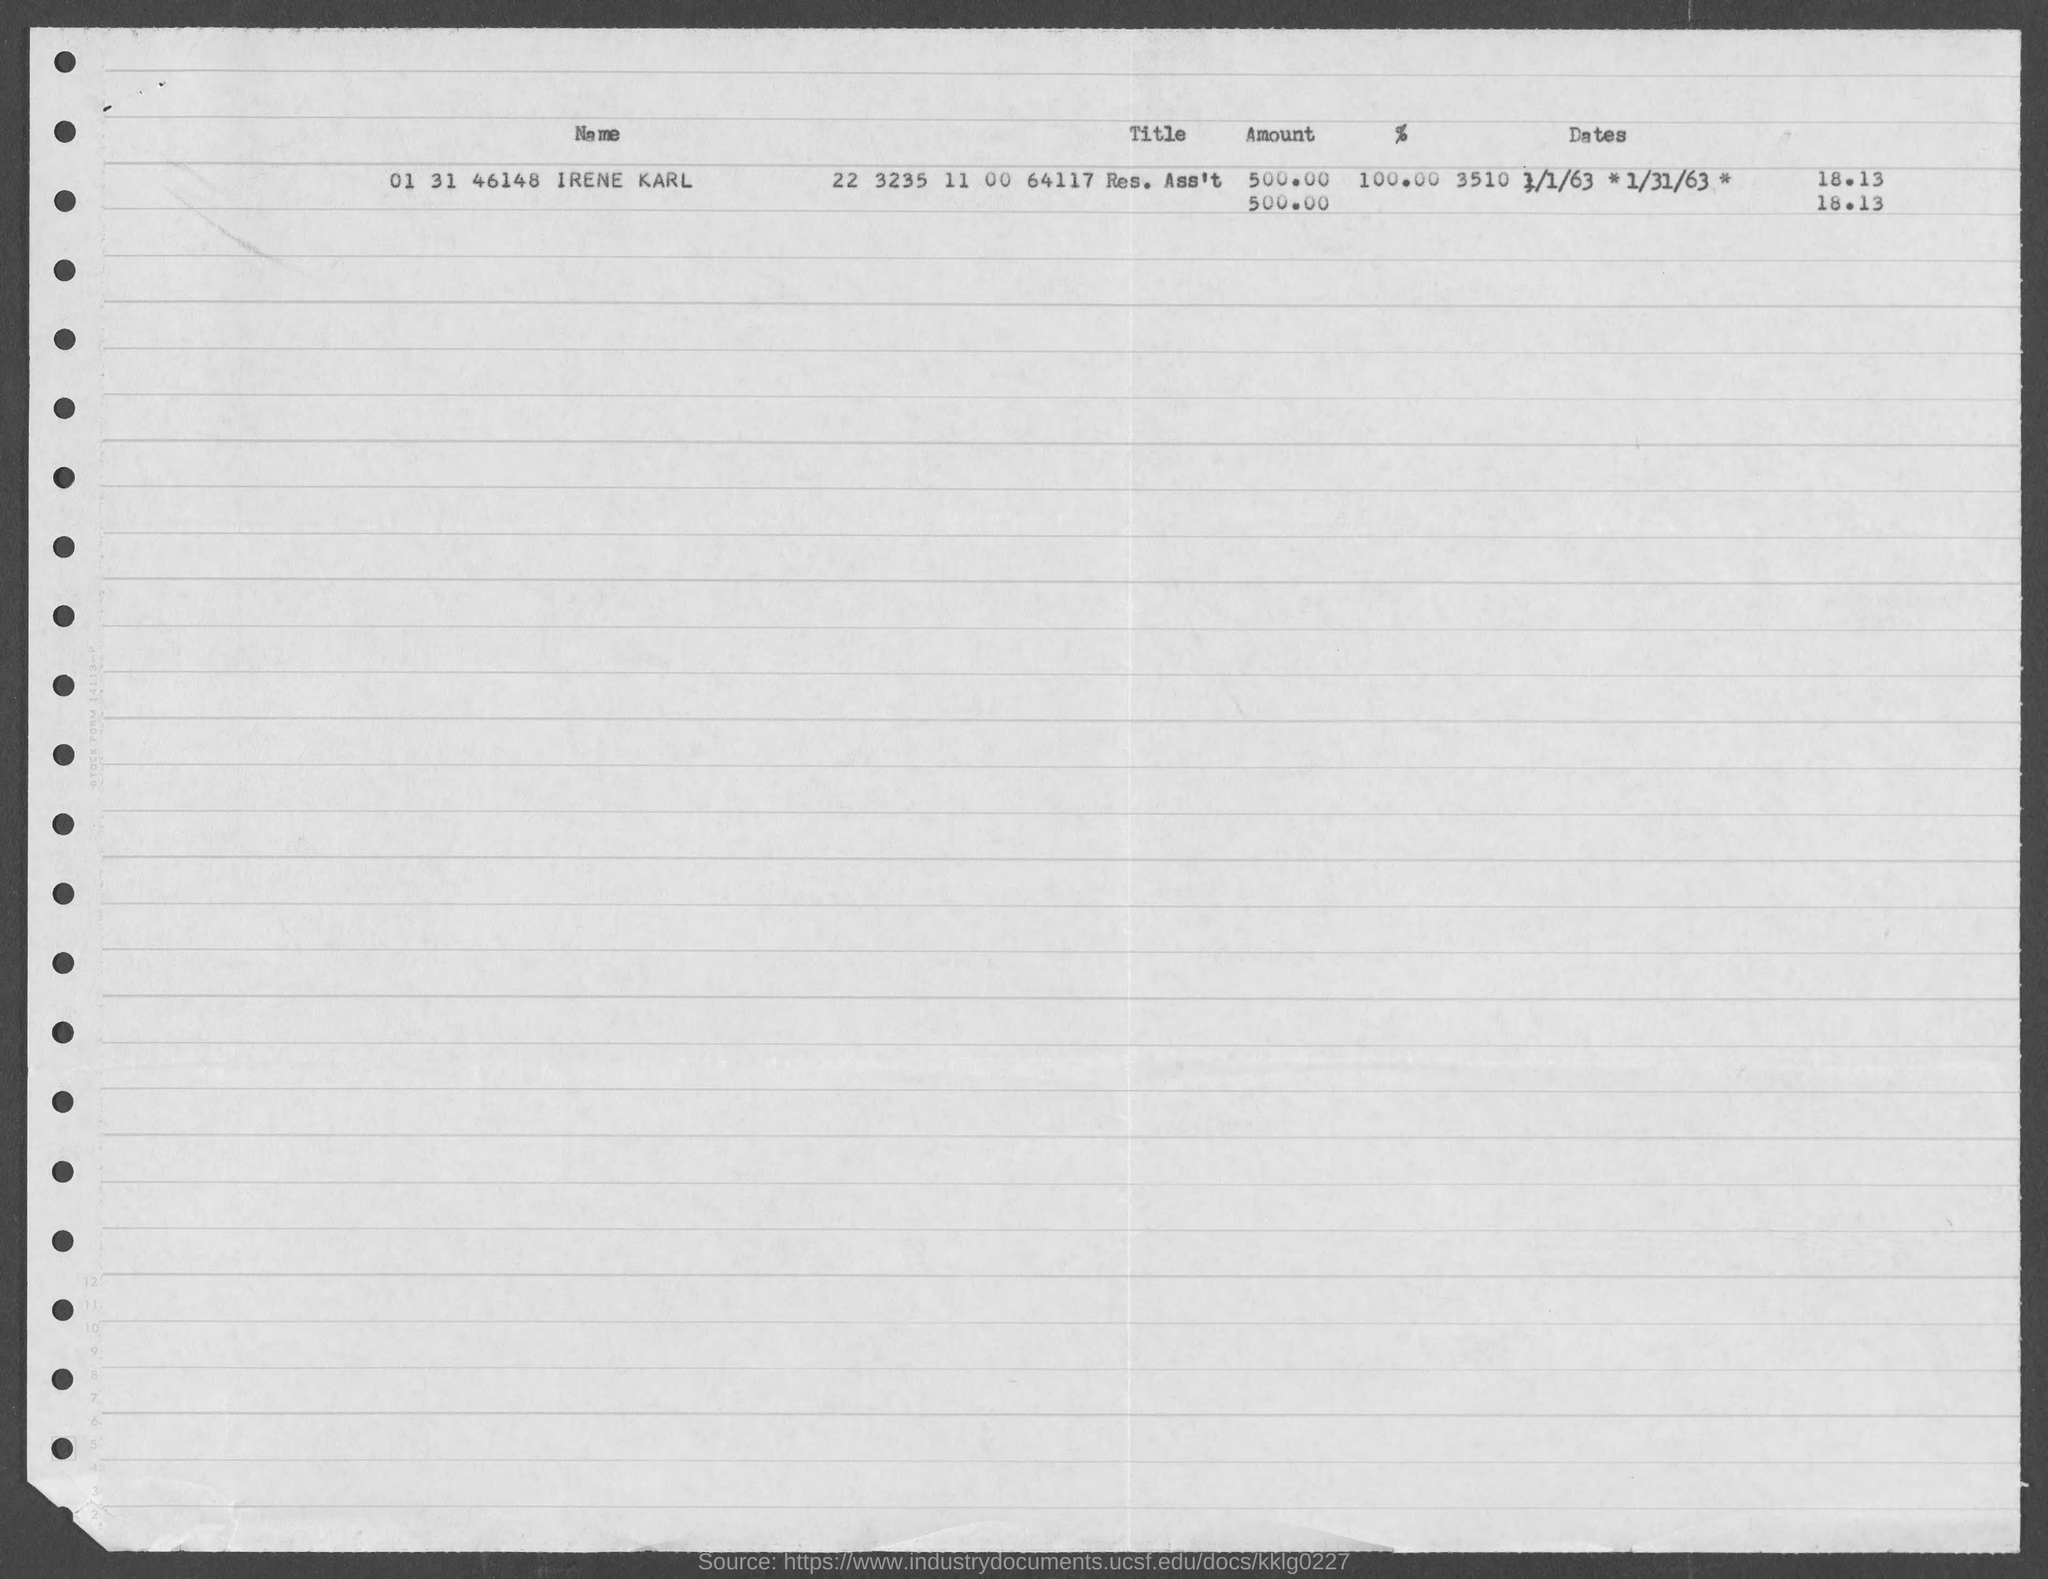What is the name given?
Keep it short and to the point. IRENE KARL. 